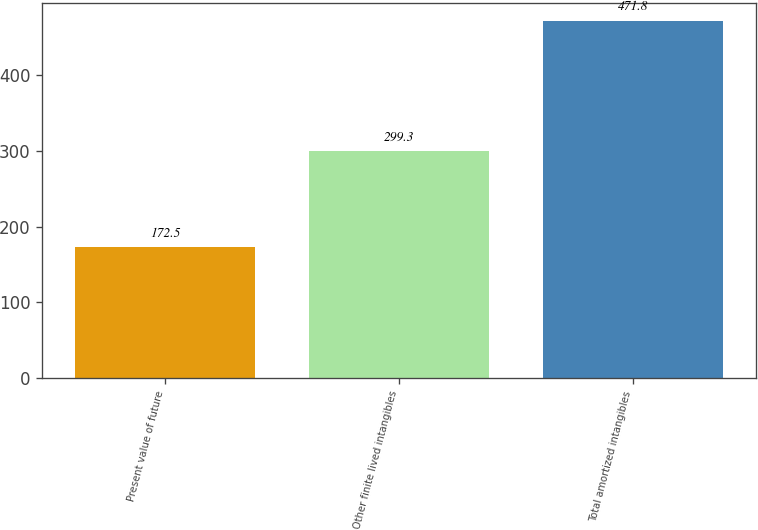Convert chart to OTSL. <chart><loc_0><loc_0><loc_500><loc_500><bar_chart><fcel>Present value of future<fcel>Other finite lived intangibles<fcel>Total amortized intangibles<nl><fcel>172.5<fcel>299.3<fcel>471.8<nl></chart> 